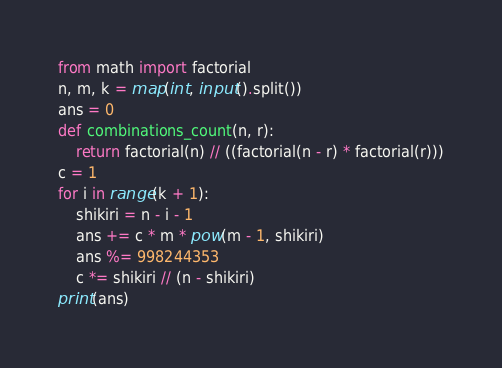Convert code to text. <code><loc_0><loc_0><loc_500><loc_500><_Python_>from math import factorial
n, m, k = map(int, input().split())
ans = 0
def combinations_count(n, r):
    return factorial(n) // ((factorial(n - r) * factorial(r)))
c = 1
for i in range(k + 1):
    shikiri = n - i - 1
    ans += c * m * pow(m - 1, shikiri)
    ans %= 998244353
    c *= shikiri // (n - shikiri)
print(ans)</code> 